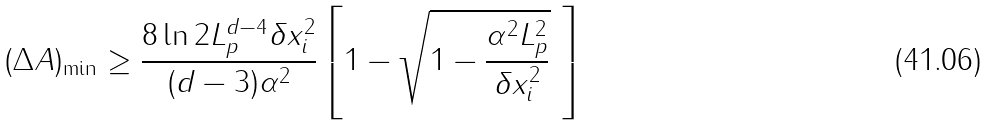<formula> <loc_0><loc_0><loc_500><loc_500>( \Delta A ) _ { \min } \geq \frac { 8 \ln 2 L _ { p } ^ { d - 4 } \delta x _ { i } ^ { 2 } } { ( d - 3 ) \alpha ^ { 2 } } \left [ 1 - \sqrt { 1 - \frac { \alpha ^ { 2 } L _ { p } ^ { 2 } } { \delta x _ { i } ^ { 2 } } } \ \right ]</formula> 